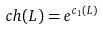<formula> <loc_0><loc_0><loc_500><loc_500>c h ( L ) = e ^ { c _ { 1 } ( L ) }</formula> 